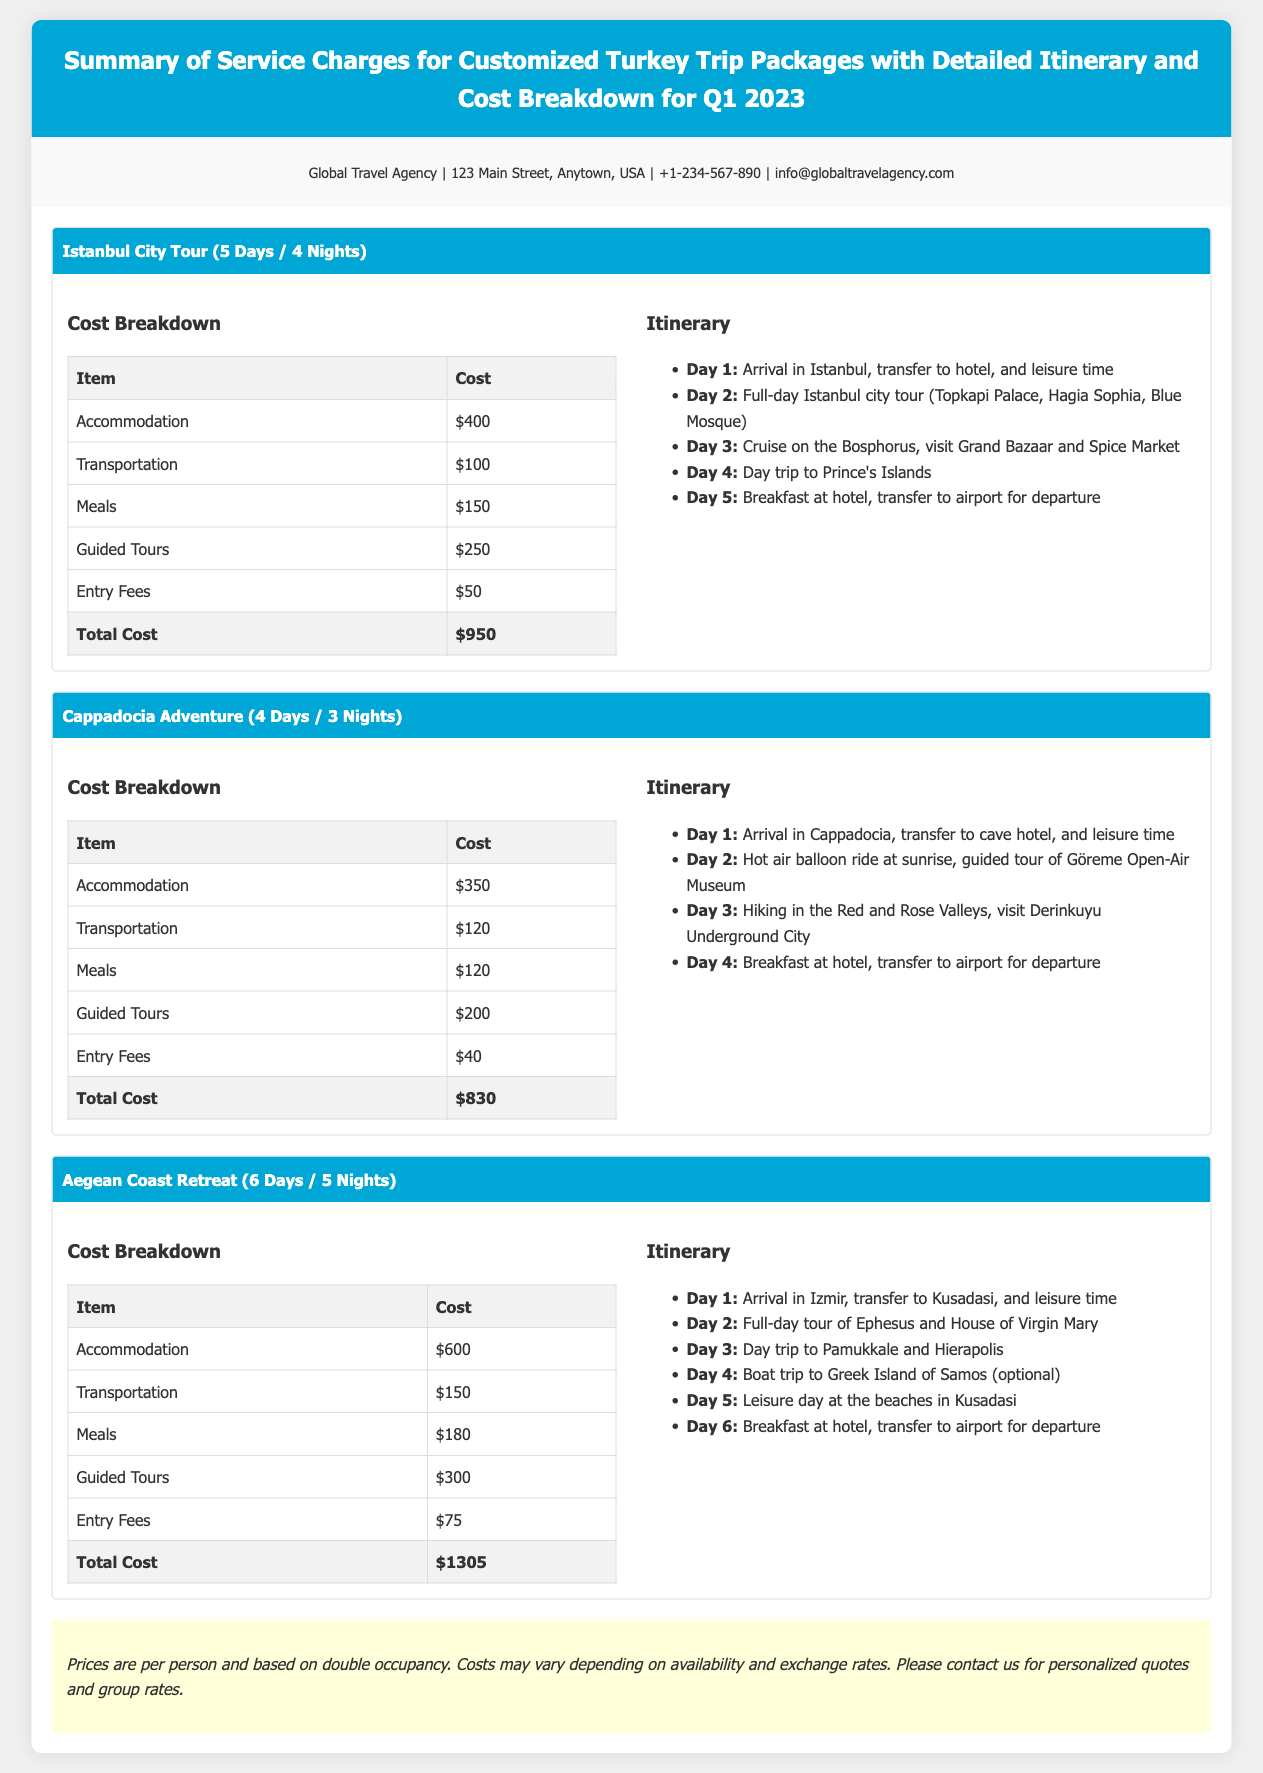What is the total cost for the Istanbul City Tour? The total cost for the Istanbul City Tour is summarized in the cost breakdown, which is $950.
Answer: $950 How many nights is the Cappadocia Adventure tour? The Cappadocia Adventure is specified in the package title as a 3-night tour.
Answer: 3 Nights What activities are included on Day 2 of the Aegean Coast Retreat? The itinerary mentions a full-day tour of Ephesus and the House of Virgin Mary for Day 2.
Answer: Full-day tour of Ephesus and House of Virgin Mary What is the cost for guided tours in the Cappadocia Adventure? The cost breakdown lists guided tours as $200 in the Cappadocia Adventure package.
Answer: $200 How many days does the Istanbul City Tour last? The length of the Istanbul City Tour is indicated in the package title as 5 days.
Answer: 5 Days What is the total cost for the Aegean Coast Retreat? The total cost for the Aegean Coast Retreat is detailed in the cost breakdown, which is $1305.
Answer: $1305 What is the price range for accommodation across all three packages? The accommodation costs range from $350 to $600 across the different packages.
Answer: $350 to $600 What type of document is this? The document is a summary of service charges for customized trip packages, specifically focused on Turkey trips.
Answer: Summary of Service Charges for Customized Turkey Trip Packages 